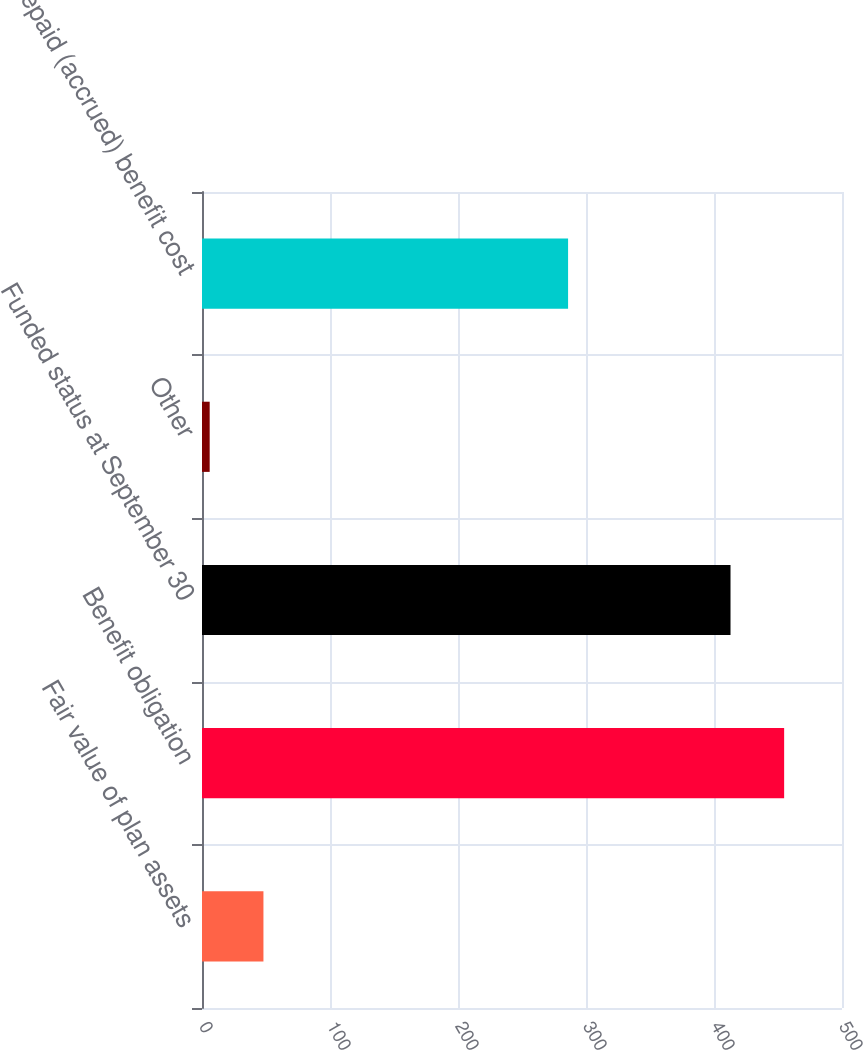Convert chart. <chart><loc_0><loc_0><loc_500><loc_500><bar_chart><fcel>Fair value of plan assets<fcel>Benefit obligation<fcel>Funded status at September 30<fcel>Other<fcel>Prepaid (accrued) benefit cost<nl><fcel>48<fcel>454.8<fcel>412.9<fcel>6<fcel>286<nl></chart> 